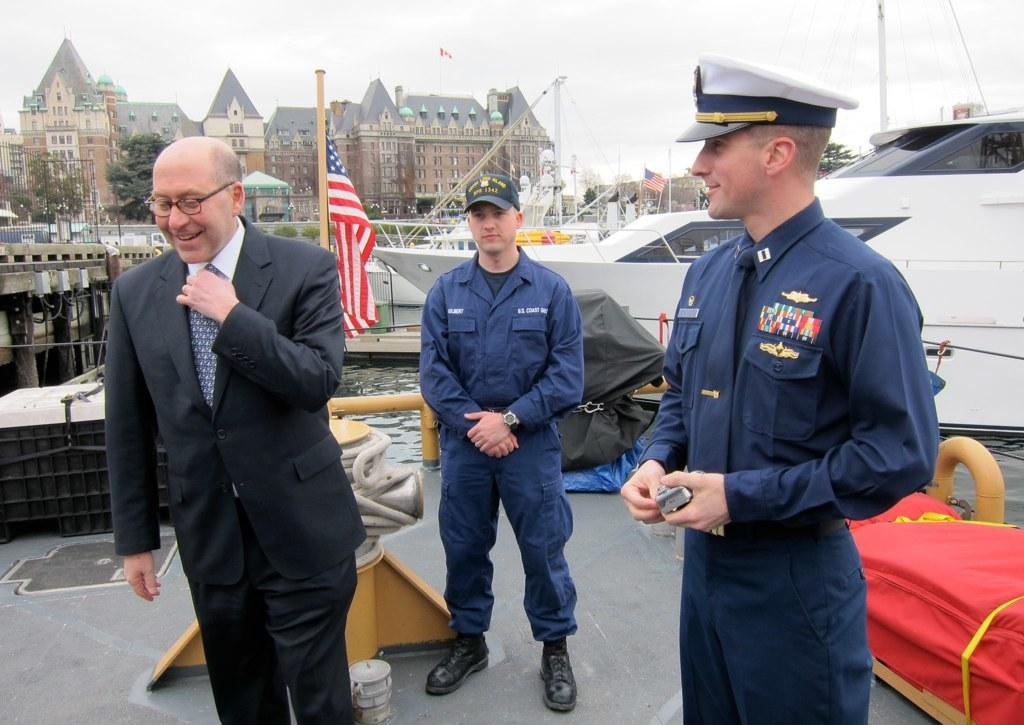How many people are in the image? There are three men standing in the image. What can be seen in the background of the image? There are buildings, trees, and a flag in the background of the image. What type of hammer is being used by one of the men in the image? There is no hammer present in the image; the three men are simply standing. 